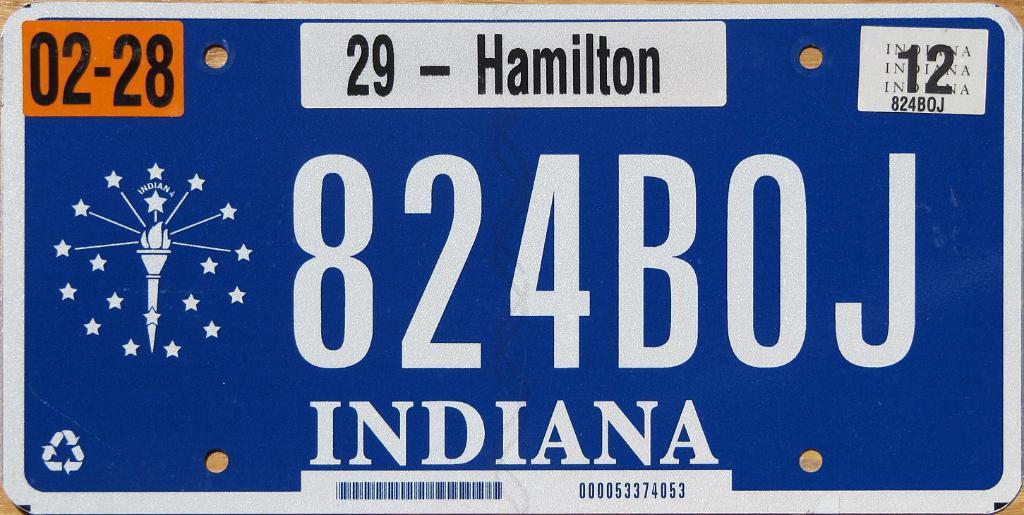Which state issue this licence?
Your answer should be very brief. Indiana. 